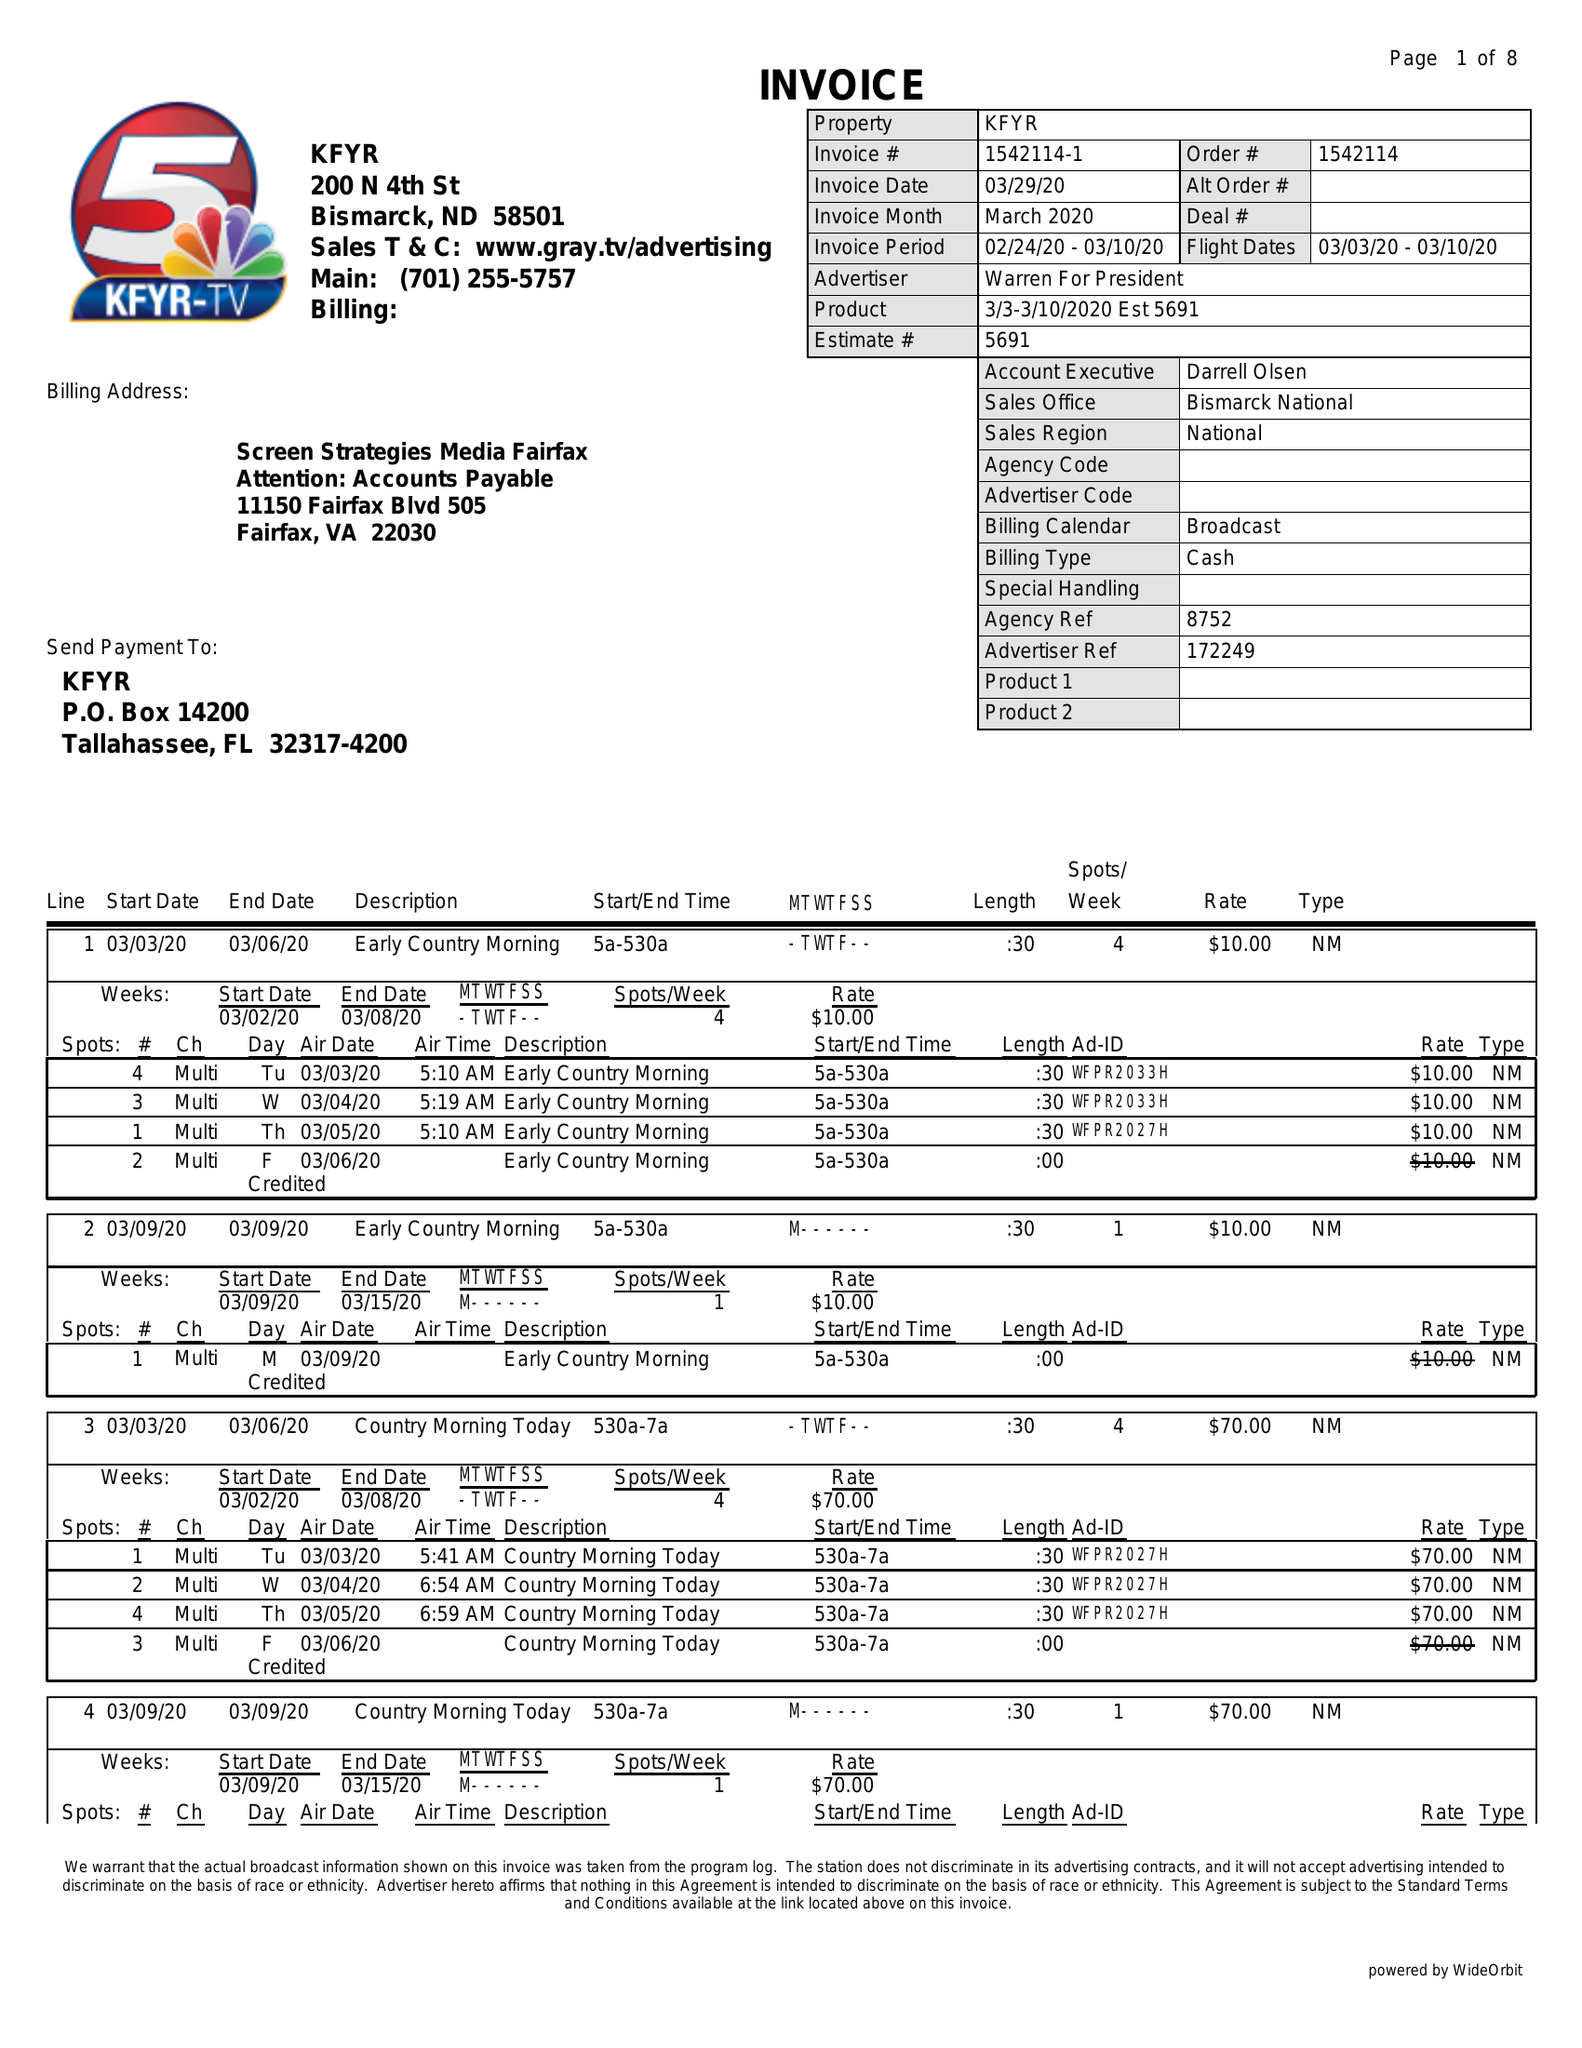What is the value for the flight_to?
Answer the question using a single word or phrase. 03/10/20 